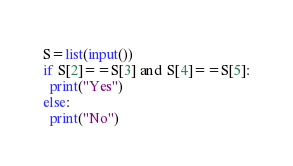<code> <loc_0><loc_0><loc_500><loc_500><_Python_>S=list(input())
if S[2]==S[3] and S[4]==S[5]:
  print("Yes")
else:
  print("No")</code> 